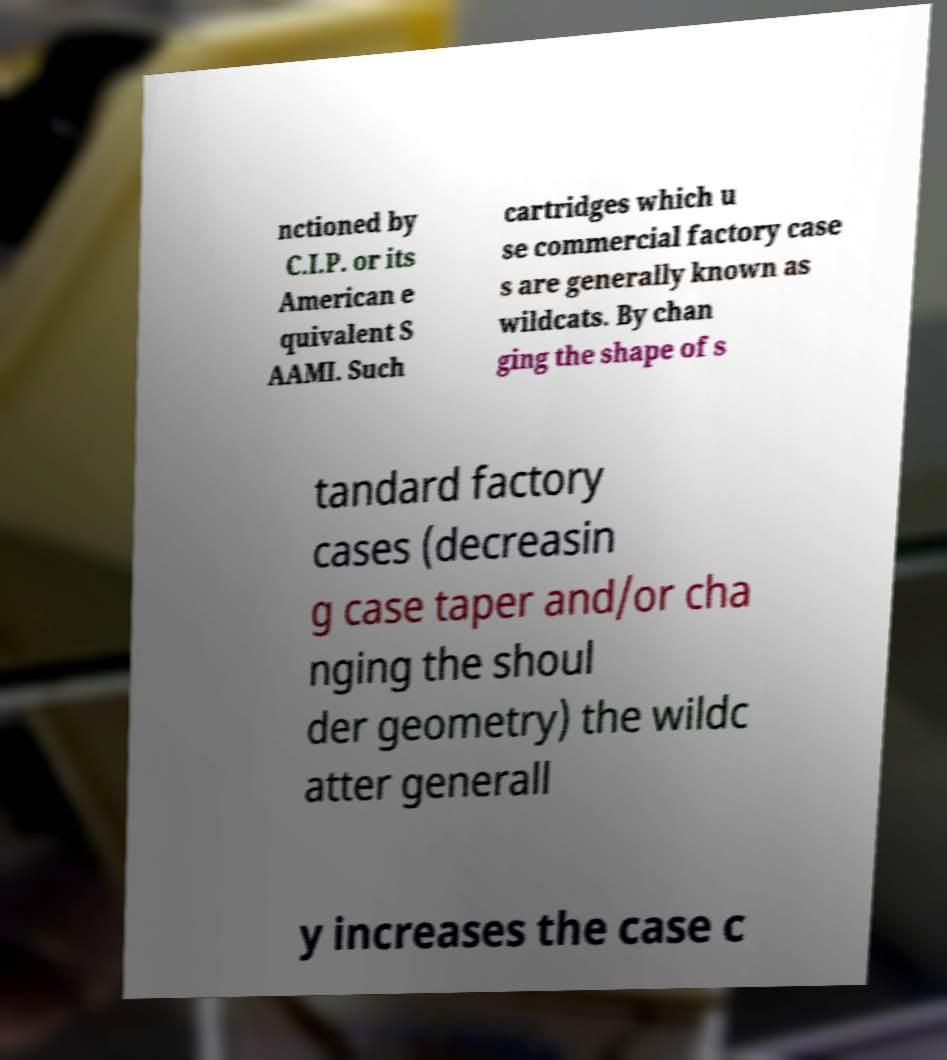Can you read and provide the text displayed in the image?This photo seems to have some interesting text. Can you extract and type it out for me? nctioned by C.I.P. or its American e quivalent S AAMI. Such cartridges which u se commercial factory case s are generally known as wildcats. By chan ging the shape of s tandard factory cases (decreasin g case taper and/or cha nging the shoul der geometry) the wildc atter generall y increases the case c 